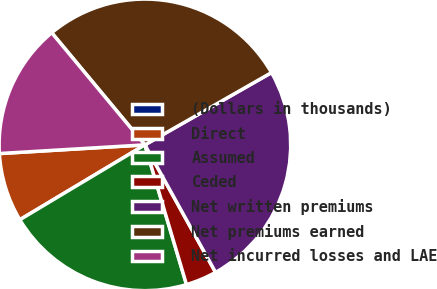Convert chart to OTSL. <chart><loc_0><loc_0><loc_500><loc_500><pie_chart><fcel>(Dollars in thousands)<fcel>Direct<fcel>Assumed<fcel>Ceded<fcel>Net written premiums<fcel>Net premiums earned<fcel>Net incurred losses and LAE<nl><fcel>0.01%<fcel>7.63%<fcel>21.02%<fcel>3.45%<fcel>25.2%<fcel>27.78%<fcel>14.91%<nl></chart> 